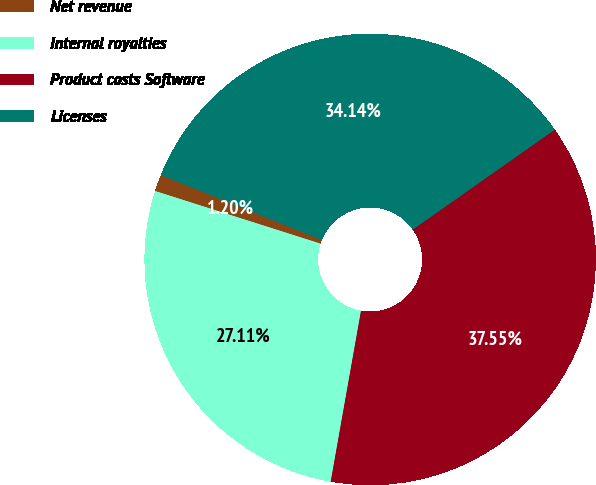<chart> <loc_0><loc_0><loc_500><loc_500><pie_chart><fcel>Net revenue<fcel>Internal royalties<fcel>Product costs Software<fcel>Licenses<nl><fcel>1.2%<fcel>27.11%<fcel>37.55%<fcel>34.14%<nl></chart> 